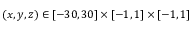Convert formula to latex. <formula><loc_0><loc_0><loc_500><loc_500>( x , y , z ) \in [ - 3 0 , 3 0 ] \times [ - 1 , 1 ] \times [ - 1 , 1 ]</formula> 